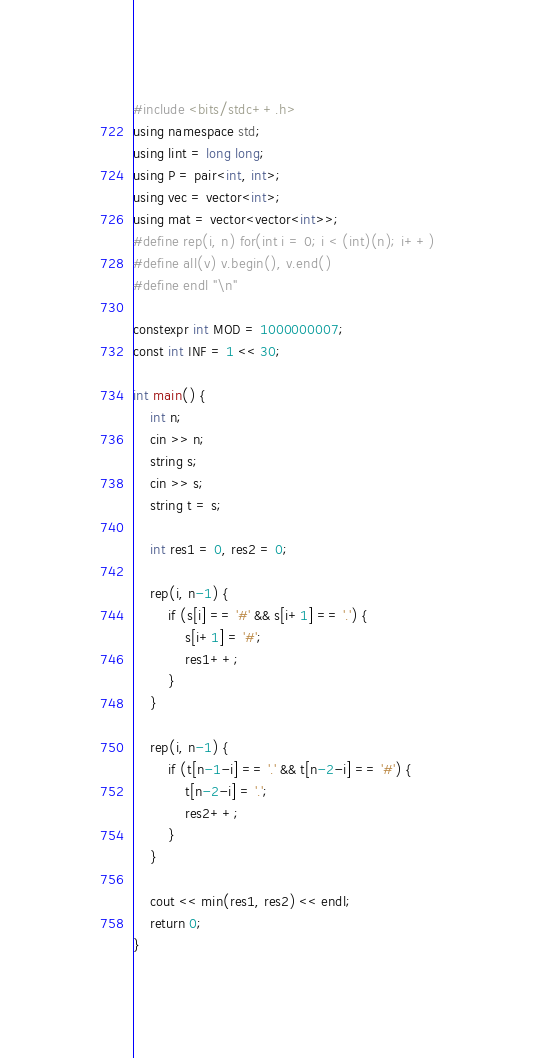<code> <loc_0><loc_0><loc_500><loc_500><_C++_>#include <bits/stdc++.h>
using namespace std;
using lint = long long;
using P = pair<int, int>;
using vec = vector<int>;
using mat = vector<vector<int>>;
#define rep(i, n) for(int i = 0; i < (int)(n); i++)
#define all(v) v.begin(), v.end()
#define endl "\n"

constexpr int MOD = 1000000007;
const int INF = 1 << 30;

int main() {
    int n;
    cin >> n;
    string s;
    cin >> s;
    string t = s;

    int res1 = 0, res2 = 0;

    rep(i, n-1) {
        if (s[i] == '#' && s[i+1] == '.') {
            s[i+1] = '#';
            res1++;
        }
    }

    rep(i, n-1) {
        if (t[n-1-i] == '.' && t[n-2-i] == '#') {
            t[n-2-i] = '.';
            res2++;
        }
    }

    cout << min(res1, res2) << endl;
    return 0;
}</code> 